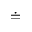Convert formula to latex. <formula><loc_0><loc_0><loc_500><loc_500>\doteq</formula> 